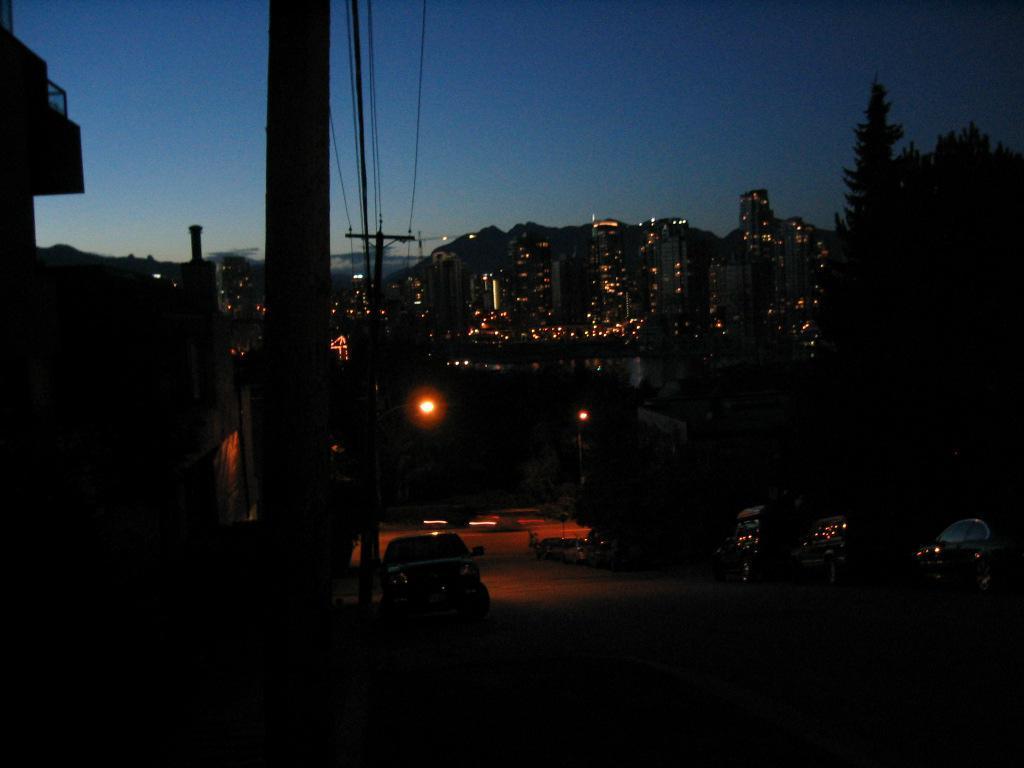Can you describe this image briefly? In this picture I can see vehicles on the road, there are poles, lights, trees, cables, buildings, and in the background there is sky. 